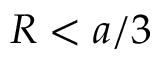<formula> <loc_0><loc_0><loc_500><loc_500>R < a / 3</formula> 